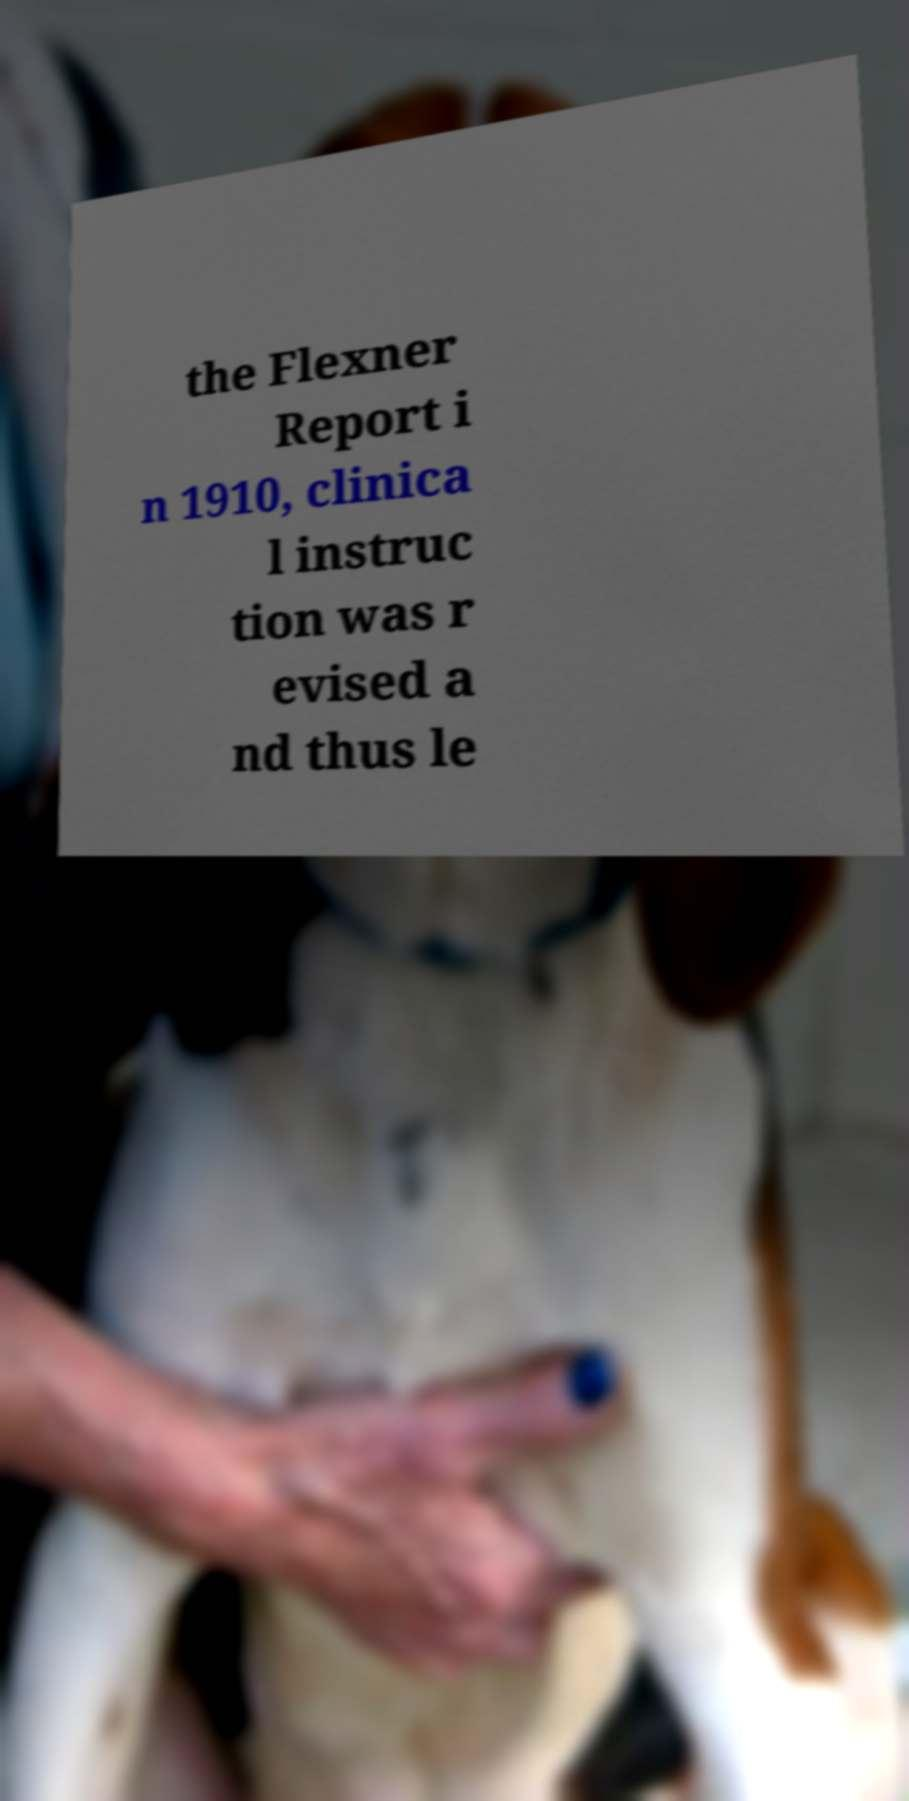Please identify and transcribe the text found in this image. the Flexner Report i n 1910, clinica l instruc tion was r evised a nd thus le 